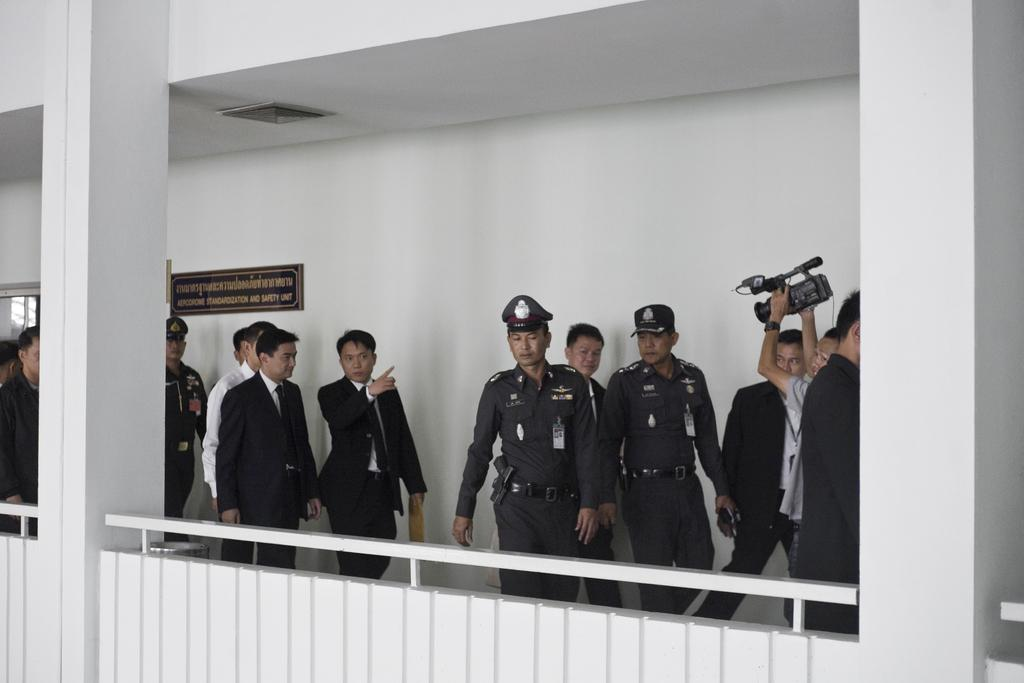How many people are in the image? There is a group of people in the image. What architectural features can be seen in the image? There are pillars and a fence visible in the image. Who is holding a camera in the image? There is a person holding a camera in the image. What is written on the wall in the background of the image? There is a name board on the wall in the background of the image. What can be seen in the background of the image besides the name board? There are objects visible in the background of the image. Where is the toy located in the image? There is no toy present in the image. What type of rod is being used by the person in the image? There is no rod being used by anyone in the image. 